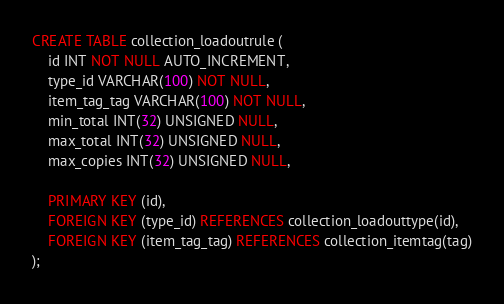Convert code to text. <code><loc_0><loc_0><loc_500><loc_500><_SQL_>CREATE TABLE collection_loadoutrule (
    id INT NOT NULL AUTO_INCREMENT,
    type_id VARCHAR(100) NOT NULL,
    item_tag_tag VARCHAR(100) NOT NULL,
    min_total INT(32) UNSIGNED NULL,
    max_total INT(32) UNSIGNED NULL,
    max_copies INT(32) UNSIGNED NULL,

    PRIMARY KEY (id),
    FOREIGN KEY (type_id) REFERENCES collection_loadouttype(id),
    FOREIGN KEY (item_tag_tag) REFERENCES collection_itemtag(tag)
);
</code> 